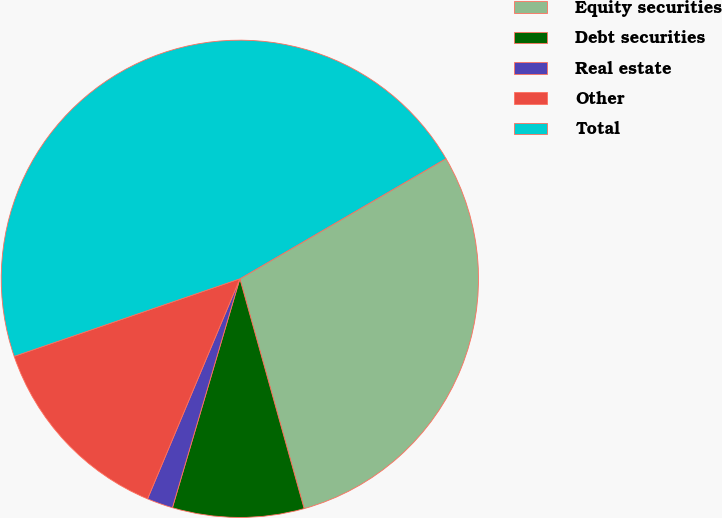<chart> <loc_0><loc_0><loc_500><loc_500><pie_chart><fcel>Equity securities<fcel>Debt securities<fcel>Real estate<fcel>Other<fcel>Total<nl><fcel>29.06%<fcel>8.9%<fcel>1.76%<fcel>13.41%<fcel>46.86%<nl></chart> 